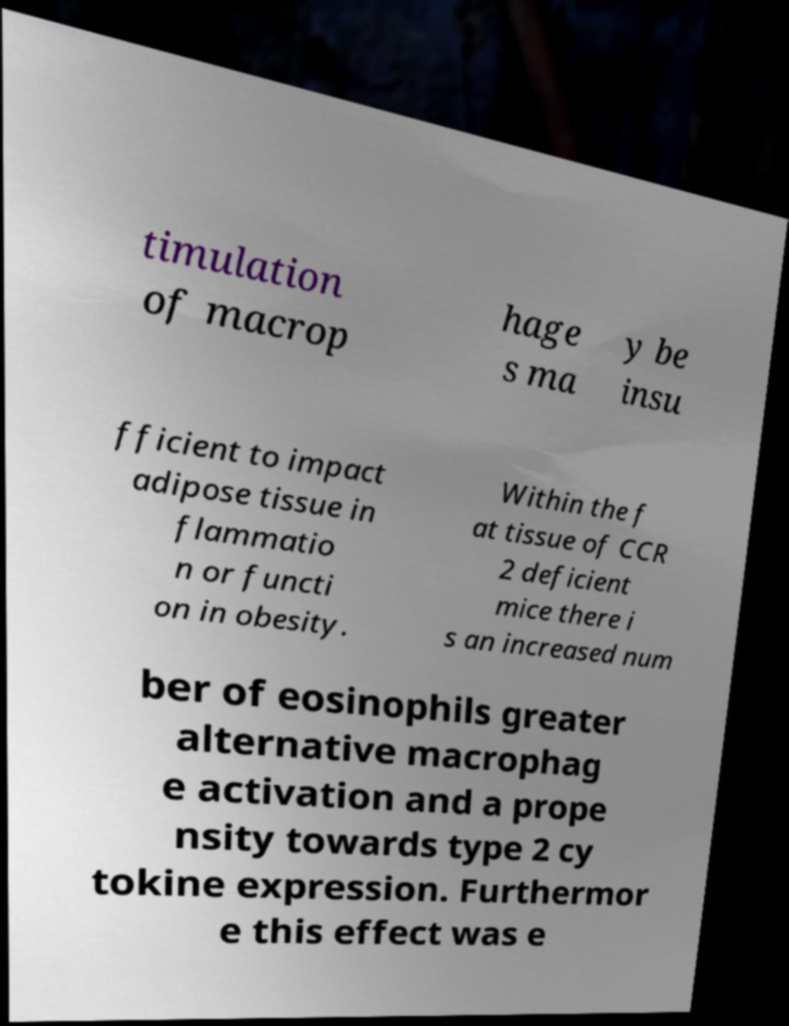Can you read and provide the text displayed in the image?This photo seems to have some interesting text. Can you extract and type it out for me? timulation of macrop hage s ma y be insu fficient to impact adipose tissue in flammatio n or functi on in obesity. Within the f at tissue of CCR 2 deficient mice there i s an increased num ber of eosinophils greater alternative macrophag e activation and a prope nsity towards type 2 cy tokine expression. Furthermor e this effect was e 